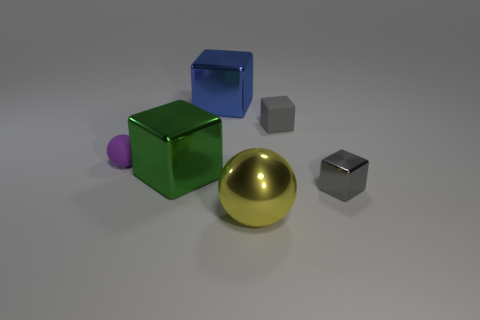There is a rubber thing that is the same color as the small shiny cube; what is its shape?
Provide a succinct answer. Cube. The shiny ball has what color?
Offer a very short reply. Yellow. Are there more gray matte things than small blue matte blocks?
Your answer should be compact. Yes. What number of objects are green metallic blocks that are left of the small rubber cube or small gray objects?
Ensure brevity in your answer.  3. Do the yellow object and the blue block have the same material?
Your response must be concise. Yes. What is the size of the gray rubber object that is the same shape as the big blue shiny object?
Offer a very short reply. Small. Is the shape of the tiny object that is to the left of the large yellow sphere the same as the big object that is in front of the green shiny object?
Give a very brief answer. Yes. There is a purple thing; is it the same size as the rubber thing on the right side of the large yellow ball?
Your answer should be compact. Yes. How many other objects are the same material as the large blue cube?
Your answer should be compact. 3. There is a small object that is left of the sphere in front of the shiny block to the right of the big sphere; what is its color?
Your response must be concise. Purple. 